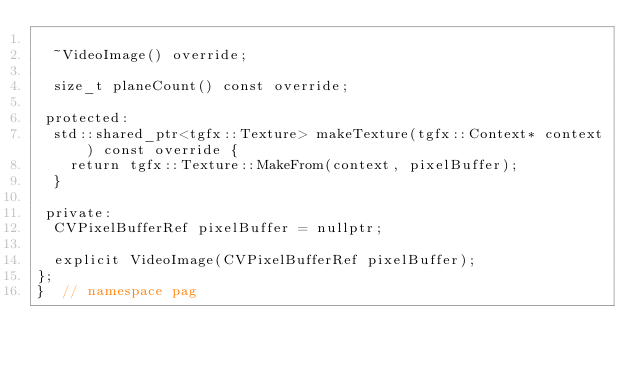Convert code to text. <code><loc_0><loc_0><loc_500><loc_500><_C_>
  ~VideoImage() override;

  size_t planeCount() const override;

 protected:
  std::shared_ptr<tgfx::Texture> makeTexture(tgfx::Context* context) const override {
    return tgfx::Texture::MakeFrom(context, pixelBuffer);
  }

 private:
  CVPixelBufferRef pixelBuffer = nullptr;

  explicit VideoImage(CVPixelBufferRef pixelBuffer);
};
}  // namespace pag
</code> 